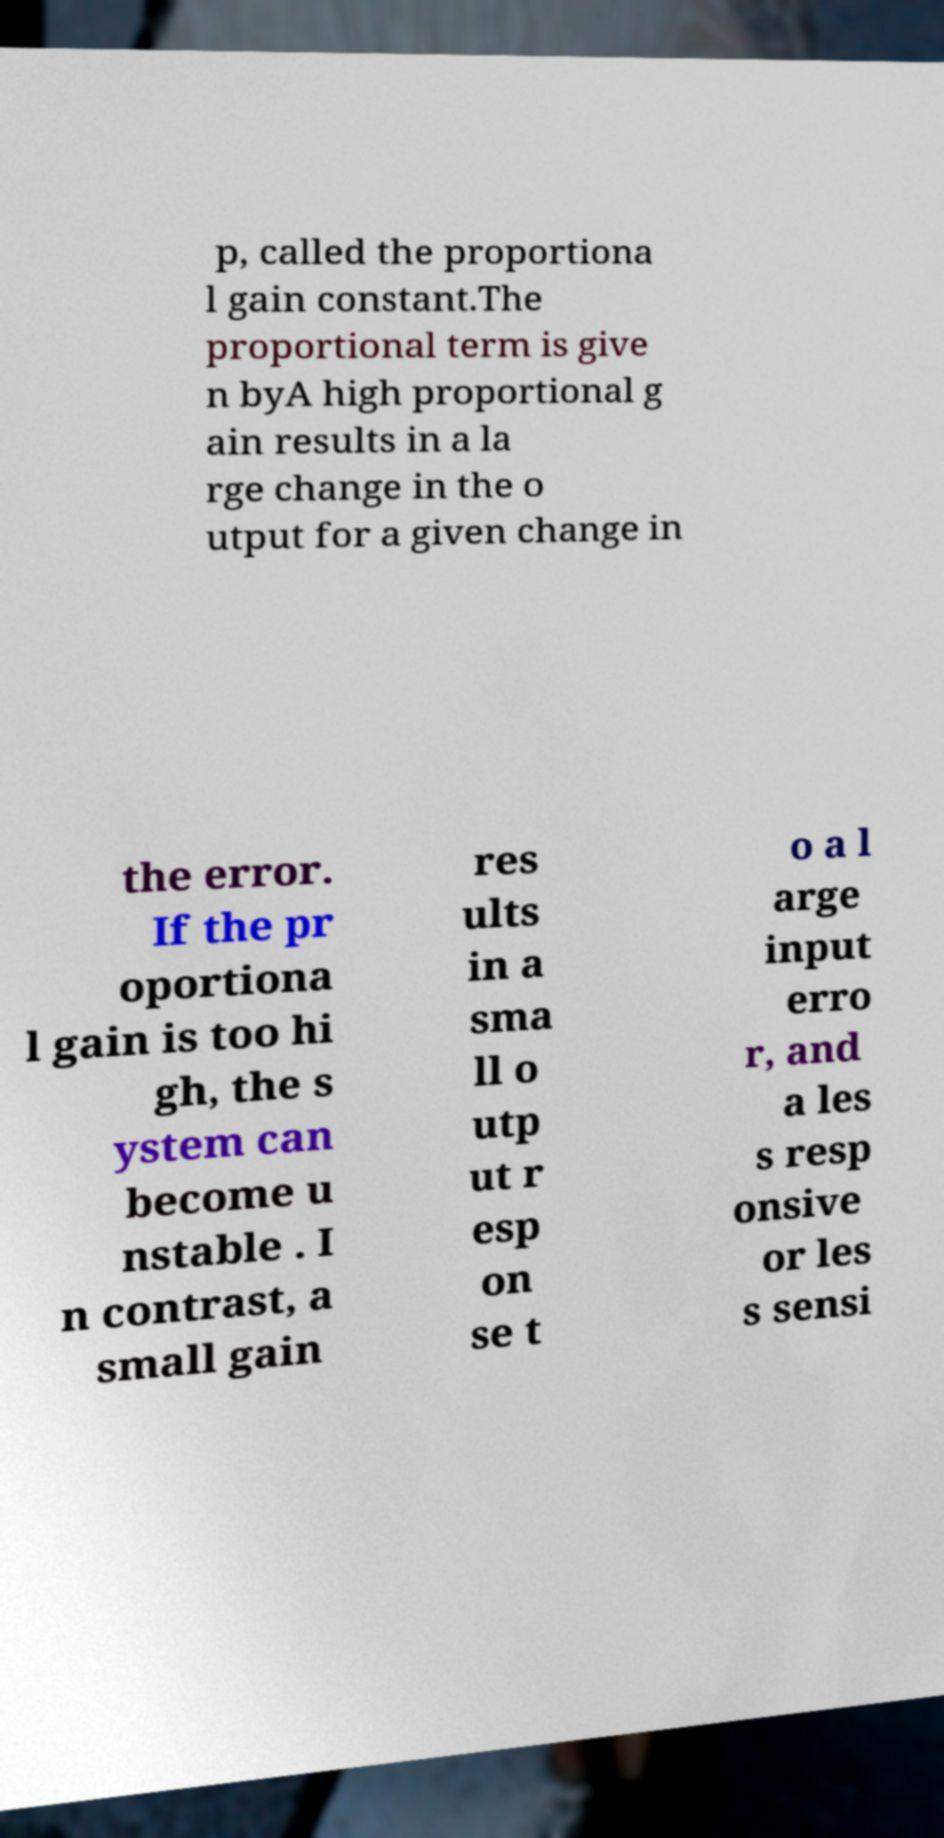Could you assist in decoding the text presented in this image and type it out clearly? p, called the proportiona l gain constant.The proportional term is give n byA high proportional g ain results in a la rge change in the o utput for a given change in the error. If the pr oportiona l gain is too hi gh, the s ystem can become u nstable . I n contrast, a small gain res ults in a sma ll o utp ut r esp on se t o a l arge input erro r, and a les s resp onsive or les s sensi 